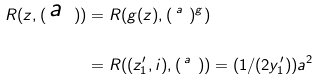Convert formula to latex. <formula><loc_0><loc_0><loc_500><loc_500>R ( z , ( \begin{smallmatrix} a & \\ & \end{smallmatrix} ) ) & = R ( g ( z ) , ( \begin{smallmatrix} a & \\ & \end{smallmatrix} ) ^ { g } ) \\ & = R ( ( z ^ { \prime } _ { 1 } , i ) , ( \begin{smallmatrix} a & \\ & \end{smallmatrix} ) ) = ( 1 / ( 2 y ^ { \prime } _ { 1 } ) ) a ^ { 2 }</formula> 